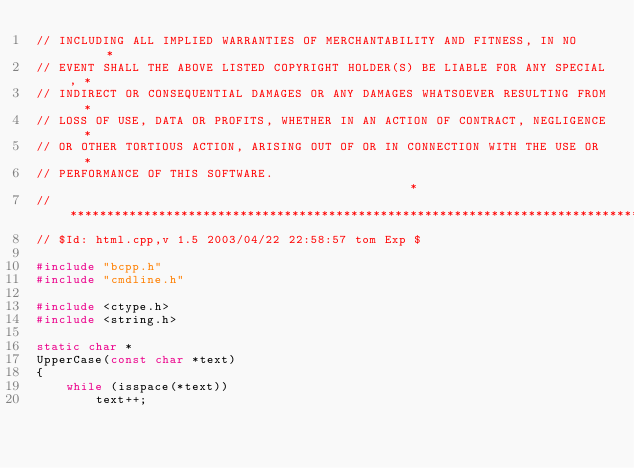<code> <loc_0><loc_0><loc_500><loc_500><_C++_>// INCLUDING ALL IMPLIED WARRANTIES OF MERCHANTABILITY AND FITNESS, IN NO      *
// EVENT SHALL THE ABOVE LISTED COPYRIGHT HOLDER(S) BE LIABLE FOR ANY SPECIAL, *
// INDIRECT OR CONSEQUENTIAL DAMAGES OR ANY DAMAGES WHATSOEVER RESULTING FROM  *
// LOSS OF USE, DATA OR PROFITS, WHETHER IN AN ACTION OF CONTRACT, NEGLIGENCE  *
// OR OTHER TORTIOUS ACTION, ARISING OUT OF OR IN CONNECTION WITH THE USE OR   *
// PERFORMANCE OF THIS SOFTWARE.                                               *
//******************************************************************************
// $Id: html.cpp,v 1.5 2003/04/22 22:58:57 tom Exp $

#include "bcpp.h"
#include "cmdline.h"

#include <ctype.h>
#include <string.h>

static char *
UpperCase(const char *text)
{
    while (isspace(*text))
        text++;</code> 